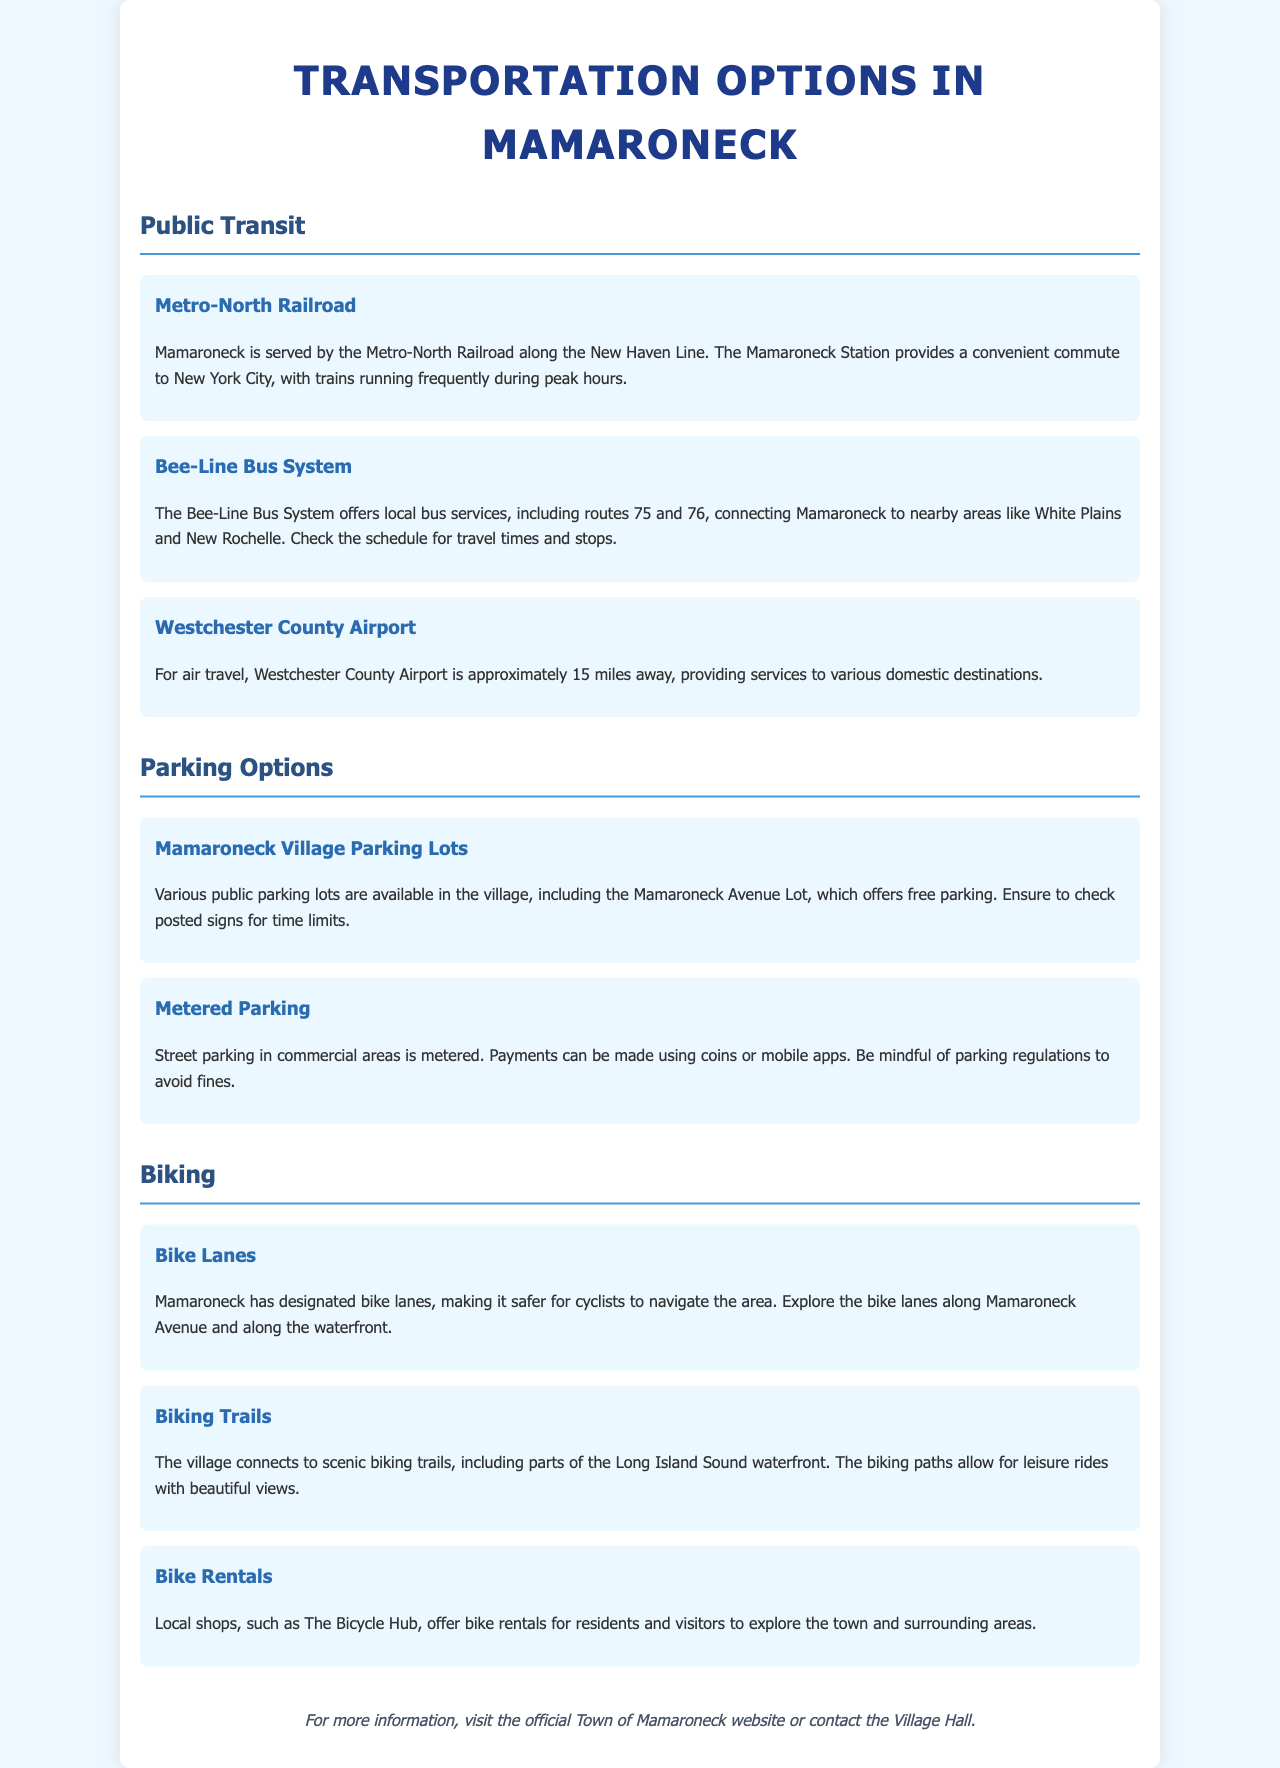What service does the Metro-North Railroad provide? The Metro-North Railroad provides a convenient commute to New York City.
Answer: Commute to New York City What are the two bus routes mentioned in the Bee-Line Bus System? The document specifies routes 75 and 76 of the Bee-Line Bus System.
Answer: 75 and 76 How far is Westchester County Airport from Mamaroneck? The document states that Westchester County Airport is approximately 15 miles away.
Answer: 15 miles What type of parking is available at the Mamaroneck Avenue Lot? The document indicates that the Mamaroneck Avenue Lot offers free parking.
Answer: Free parking What payment methods are available for metered parking? The document mentions that payments can be made using coins or mobile apps.
Answer: Coins or mobile apps Where can you find bike rentals in Mamaroneck? The document specifies that The Bicycle Hub offers bike rentals for residents and visitors.
Answer: The Bicycle Hub What is one benefit of Mamaroneck's bike lanes? The document states that bike lanes make it safer for cyclists to navigate the area.
Answer: Safer navigation What scenic feature do the biking trails connect to? The document mentions that the biking trails include parts of the Long Island Sound waterfront.
Answer: Long Island Sound waterfront What information is available for further inquiries? The document instructs to visit the official Town of Mamaroneck website or contact Village Hall for more information.
Answer: Official Town website or Village Hall 